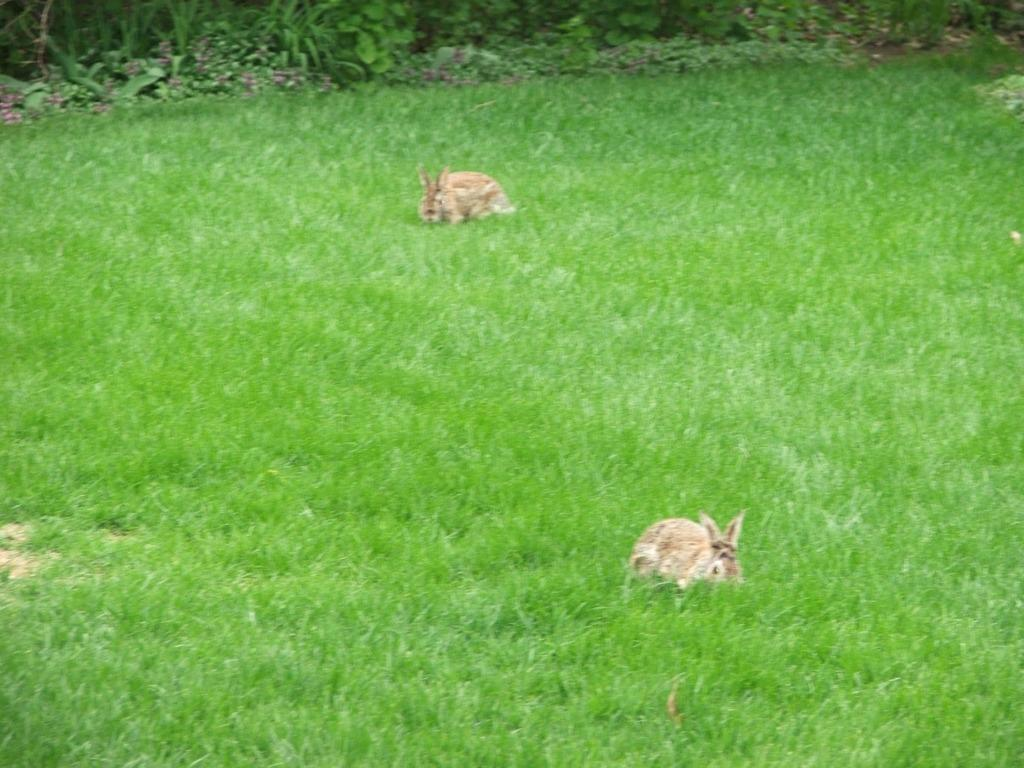What type of environment is shown in the image? The image depicts a grassy land. Can you identify any animals in the image? Yes, there are two rabbits in the image. What else can be seen in the image besides the grassy land and rabbits? There are many plants in the image. How is the water being used by the rabbits in the image? There is no water present in the image; it depicts a grassy land with two rabbits and many plants. 